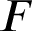<formula> <loc_0><loc_0><loc_500><loc_500>F</formula> 